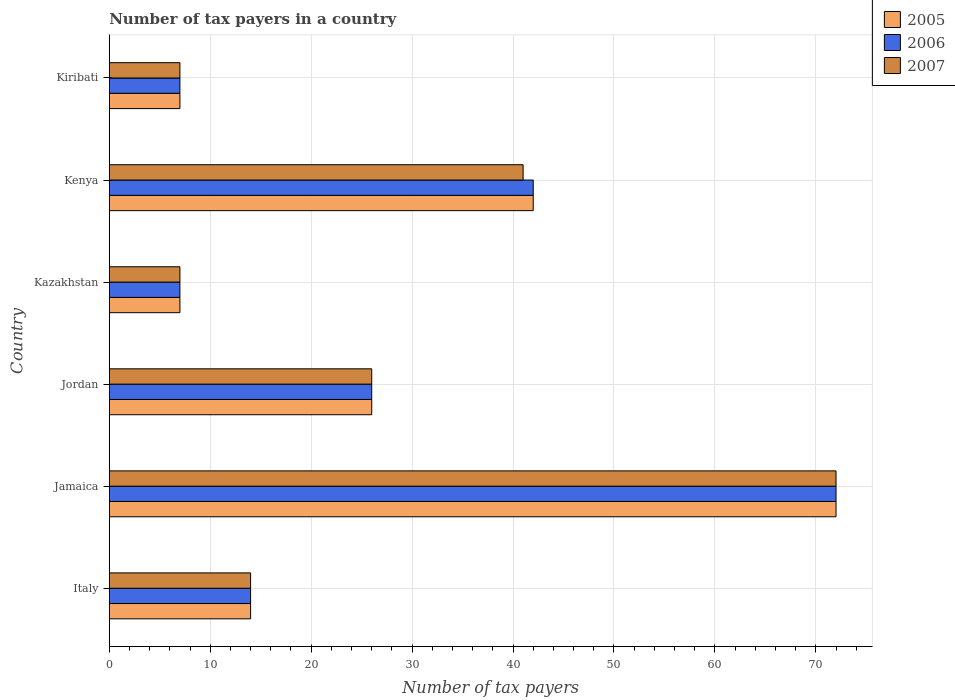How many bars are there on the 4th tick from the top?
Make the answer very short. 3. What is the label of the 3rd group of bars from the top?
Your answer should be compact. Kazakhstan. Across all countries, what is the maximum number of tax payers in in 2007?
Keep it short and to the point. 72. Across all countries, what is the minimum number of tax payers in in 2005?
Keep it short and to the point. 7. In which country was the number of tax payers in in 2006 maximum?
Provide a succinct answer. Jamaica. In which country was the number of tax payers in in 2006 minimum?
Offer a very short reply. Kazakhstan. What is the total number of tax payers in in 2007 in the graph?
Provide a succinct answer. 167. What is the difference between the number of tax payers in in 2007 in Jamaica and that in Kazakhstan?
Provide a short and direct response. 65. What is the difference between the number of tax payers in in 2007 in Italy and the number of tax payers in in 2005 in Jamaica?
Provide a short and direct response. -58. What is the difference between the number of tax payers in in 2006 and number of tax payers in in 2007 in Kenya?
Provide a succinct answer. 1. What is the ratio of the number of tax payers in in 2007 in Jordan to that in Kiribati?
Your response must be concise. 3.71. Is the difference between the number of tax payers in in 2006 in Jamaica and Kiribati greater than the difference between the number of tax payers in in 2007 in Jamaica and Kiribati?
Provide a succinct answer. No. What is the difference between the highest and the second highest number of tax payers in in 2005?
Your answer should be compact. 30. What is the difference between the highest and the lowest number of tax payers in in 2005?
Keep it short and to the point. 65. In how many countries, is the number of tax payers in in 2005 greater than the average number of tax payers in in 2005 taken over all countries?
Offer a very short reply. 2. Is the sum of the number of tax payers in in 2006 in Kazakhstan and Kiribati greater than the maximum number of tax payers in in 2005 across all countries?
Give a very brief answer. No. What does the 1st bar from the top in Kenya represents?
Your answer should be compact. 2007. What does the 1st bar from the bottom in Kenya represents?
Make the answer very short. 2005. What is the difference between two consecutive major ticks on the X-axis?
Your answer should be compact. 10. Are the values on the major ticks of X-axis written in scientific E-notation?
Give a very brief answer. No. Does the graph contain any zero values?
Offer a very short reply. No. Does the graph contain grids?
Provide a succinct answer. Yes. Where does the legend appear in the graph?
Your answer should be compact. Top right. What is the title of the graph?
Offer a terse response. Number of tax payers in a country. What is the label or title of the X-axis?
Give a very brief answer. Number of tax payers. What is the label or title of the Y-axis?
Your answer should be compact. Country. What is the Number of tax payers in 2005 in Italy?
Your answer should be very brief. 14. What is the Number of tax payers in 2006 in Italy?
Offer a terse response. 14. What is the Number of tax payers of 2006 in Jamaica?
Provide a succinct answer. 72. What is the Number of tax payers in 2007 in Jamaica?
Give a very brief answer. 72. What is the Number of tax payers in 2007 in Jordan?
Give a very brief answer. 26. What is the Number of tax payers in 2005 in Kenya?
Ensure brevity in your answer.  42. What is the Number of tax payers of 2006 in Kiribati?
Offer a terse response. 7. Across all countries, what is the maximum Number of tax payers in 2005?
Provide a short and direct response. 72. Across all countries, what is the maximum Number of tax payers of 2006?
Your response must be concise. 72. Across all countries, what is the minimum Number of tax payers in 2005?
Your response must be concise. 7. Across all countries, what is the minimum Number of tax payers in 2006?
Give a very brief answer. 7. Across all countries, what is the minimum Number of tax payers in 2007?
Provide a succinct answer. 7. What is the total Number of tax payers in 2005 in the graph?
Keep it short and to the point. 168. What is the total Number of tax payers of 2006 in the graph?
Offer a terse response. 168. What is the total Number of tax payers of 2007 in the graph?
Make the answer very short. 167. What is the difference between the Number of tax payers of 2005 in Italy and that in Jamaica?
Offer a terse response. -58. What is the difference between the Number of tax payers in 2006 in Italy and that in Jamaica?
Offer a terse response. -58. What is the difference between the Number of tax payers of 2007 in Italy and that in Jamaica?
Provide a short and direct response. -58. What is the difference between the Number of tax payers in 2006 in Italy and that in Jordan?
Give a very brief answer. -12. What is the difference between the Number of tax payers of 2007 in Italy and that in Jordan?
Keep it short and to the point. -12. What is the difference between the Number of tax payers of 2005 in Italy and that in Kazakhstan?
Provide a short and direct response. 7. What is the difference between the Number of tax payers in 2006 in Italy and that in Kenya?
Keep it short and to the point. -28. What is the difference between the Number of tax payers of 2006 in Italy and that in Kiribati?
Make the answer very short. 7. What is the difference between the Number of tax payers in 2006 in Jamaica and that in Jordan?
Your response must be concise. 46. What is the difference between the Number of tax payers of 2007 in Jamaica and that in Jordan?
Your answer should be very brief. 46. What is the difference between the Number of tax payers in 2006 in Jamaica and that in Kazakhstan?
Provide a short and direct response. 65. What is the difference between the Number of tax payers of 2007 in Jamaica and that in Kazakhstan?
Your response must be concise. 65. What is the difference between the Number of tax payers in 2005 in Jamaica and that in Kenya?
Your answer should be compact. 30. What is the difference between the Number of tax payers of 2005 in Jamaica and that in Kiribati?
Provide a succinct answer. 65. What is the difference between the Number of tax payers of 2007 in Jamaica and that in Kiribati?
Make the answer very short. 65. What is the difference between the Number of tax payers in 2006 in Jordan and that in Kazakhstan?
Ensure brevity in your answer.  19. What is the difference between the Number of tax payers in 2007 in Jordan and that in Kazakhstan?
Keep it short and to the point. 19. What is the difference between the Number of tax payers in 2005 in Jordan and that in Kenya?
Your response must be concise. -16. What is the difference between the Number of tax payers in 2006 in Jordan and that in Kenya?
Keep it short and to the point. -16. What is the difference between the Number of tax payers in 2007 in Jordan and that in Kenya?
Offer a very short reply. -15. What is the difference between the Number of tax payers in 2006 in Jordan and that in Kiribati?
Provide a short and direct response. 19. What is the difference between the Number of tax payers in 2005 in Kazakhstan and that in Kenya?
Offer a terse response. -35. What is the difference between the Number of tax payers of 2006 in Kazakhstan and that in Kenya?
Provide a short and direct response. -35. What is the difference between the Number of tax payers of 2007 in Kazakhstan and that in Kenya?
Provide a short and direct response. -34. What is the difference between the Number of tax payers of 2007 in Kazakhstan and that in Kiribati?
Provide a short and direct response. 0. What is the difference between the Number of tax payers in 2005 in Kenya and that in Kiribati?
Your response must be concise. 35. What is the difference between the Number of tax payers in 2006 in Kenya and that in Kiribati?
Your answer should be very brief. 35. What is the difference between the Number of tax payers of 2005 in Italy and the Number of tax payers of 2006 in Jamaica?
Provide a short and direct response. -58. What is the difference between the Number of tax payers of 2005 in Italy and the Number of tax payers of 2007 in Jamaica?
Keep it short and to the point. -58. What is the difference between the Number of tax payers of 2006 in Italy and the Number of tax payers of 2007 in Jamaica?
Your answer should be very brief. -58. What is the difference between the Number of tax payers in 2005 in Italy and the Number of tax payers in 2006 in Kazakhstan?
Offer a very short reply. 7. What is the difference between the Number of tax payers in 2005 in Italy and the Number of tax payers in 2007 in Kenya?
Make the answer very short. -27. What is the difference between the Number of tax payers of 2005 in Italy and the Number of tax payers of 2006 in Kiribati?
Offer a terse response. 7. What is the difference between the Number of tax payers of 2005 in Jamaica and the Number of tax payers of 2007 in Jordan?
Your answer should be compact. 46. What is the difference between the Number of tax payers in 2006 in Jamaica and the Number of tax payers in 2007 in Jordan?
Your answer should be compact. 46. What is the difference between the Number of tax payers of 2005 in Jamaica and the Number of tax payers of 2007 in Kazakhstan?
Provide a short and direct response. 65. What is the difference between the Number of tax payers of 2006 in Jamaica and the Number of tax payers of 2007 in Kazakhstan?
Ensure brevity in your answer.  65. What is the difference between the Number of tax payers of 2005 in Jamaica and the Number of tax payers of 2006 in Kenya?
Provide a succinct answer. 30. What is the difference between the Number of tax payers of 2005 in Jamaica and the Number of tax payers of 2006 in Kiribati?
Offer a terse response. 65. What is the difference between the Number of tax payers of 2005 in Jordan and the Number of tax payers of 2006 in Kazakhstan?
Offer a very short reply. 19. What is the difference between the Number of tax payers of 2006 in Jordan and the Number of tax payers of 2007 in Kazakhstan?
Your response must be concise. 19. What is the difference between the Number of tax payers of 2005 in Jordan and the Number of tax payers of 2006 in Kenya?
Provide a succinct answer. -16. What is the difference between the Number of tax payers in 2005 in Jordan and the Number of tax payers in 2007 in Kiribati?
Your answer should be compact. 19. What is the difference between the Number of tax payers in 2006 in Jordan and the Number of tax payers in 2007 in Kiribati?
Give a very brief answer. 19. What is the difference between the Number of tax payers of 2005 in Kazakhstan and the Number of tax payers of 2006 in Kenya?
Offer a terse response. -35. What is the difference between the Number of tax payers of 2005 in Kazakhstan and the Number of tax payers of 2007 in Kenya?
Keep it short and to the point. -34. What is the difference between the Number of tax payers of 2006 in Kazakhstan and the Number of tax payers of 2007 in Kenya?
Give a very brief answer. -34. What is the difference between the Number of tax payers in 2005 in Kazakhstan and the Number of tax payers in 2006 in Kiribati?
Provide a short and direct response. 0. What is the difference between the Number of tax payers of 2005 in Kazakhstan and the Number of tax payers of 2007 in Kiribati?
Provide a short and direct response. 0. What is the difference between the Number of tax payers in 2006 in Kazakhstan and the Number of tax payers in 2007 in Kiribati?
Your answer should be compact. 0. What is the difference between the Number of tax payers in 2005 in Kenya and the Number of tax payers in 2007 in Kiribati?
Your response must be concise. 35. What is the difference between the Number of tax payers of 2006 in Kenya and the Number of tax payers of 2007 in Kiribati?
Ensure brevity in your answer.  35. What is the average Number of tax payers in 2005 per country?
Make the answer very short. 28. What is the average Number of tax payers of 2007 per country?
Your answer should be very brief. 27.83. What is the difference between the Number of tax payers of 2005 and Number of tax payers of 2007 in Italy?
Your answer should be compact. 0. What is the difference between the Number of tax payers in 2005 and Number of tax payers in 2006 in Jamaica?
Offer a very short reply. 0. What is the difference between the Number of tax payers of 2005 and Number of tax payers of 2007 in Jamaica?
Keep it short and to the point. 0. What is the difference between the Number of tax payers in 2006 and Number of tax payers in 2007 in Jamaica?
Give a very brief answer. 0. What is the difference between the Number of tax payers of 2005 and Number of tax payers of 2007 in Jordan?
Make the answer very short. 0. What is the difference between the Number of tax payers in 2006 and Number of tax payers in 2007 in Jordan?
Provide a short and direct response. 0. What is the difference between the Number of tax payers of 2005 and Number of tax payers of 2006 in Kazakhstan?
Provide a short and direct response. 0. What is the difference between the Number of tax payers in 2006 and Number of tax payers in 2007 in Kazakhstan?
Offer a very short reply. 0. What is the difference between the Number of tax payers in 2005 and Number of tax payers in 2006 in Kenya?
Keep it short and to the point. 0. What is the difference between the Number of tax payers of 2005 and Number of tax payers of 2007 in Kenya?
Your response must be concise. 1. What is the difference between the Number of tax payers in 2006 and Number of tax payers in 2007 in Kenya?
Provide a short and direct response. 1. What is the difference between the Number of tax payers in 2005 and Number of tax payers in 2006 in Kiribati?
Offer a terse response. 0. What is the difference between the Number of tax payers of 2005 and Number of tax payers of 2007 in Kiribati?
Provide a short and direct response. 0. What is the ratio of the Number of tax payers in 2005 in Italy to that in Jamaica?
Your answer should be compact. 0.19. What is the ratio of the Number of tax payers of 2006 in Italy to that in Jamaica?
Your answer should be very brief. 0.19. What is the ratio of the Number of tax payers of 2007 in Italy to that in Jamaica?
Your answer should be very brief. 0.19. What is the ratio of the Number of tax payers in 2005 in Italy to that in Jordan?
Provide a short and direct response. 0.54. What is the ratio of the Number of tax payers in 2006 in Italy to that in Jordan?
Give a very brief answer. 0.54. What is the ratio of the Number of tax payers of 2007 in Italy to that in Jordan?
Make the answer very short. 0.54. What is the ratio of the Number of tax payers of 2005 in Italy to that in Kazakhstan?
Provide a succinct answer. 2. What is the ratio of the Number of tax payers in 2006 in Italy to that in Kazakhstan?
Your answer should be very brief. 2. What is the ratio of the Number of tax payers of 2007 in Italy to that in Kazakhstan?
Provide a short and direct response. 2. What is the ratio of the Number of tax payers of 2005 in Italy to that in Kenya?
Offer a terse response. 0.33. What is the ratio of the Number of tax payers of 2006 in Italy to that in Kenya?
Provide a short and direct response. 0.33. What is the ratio of the Number of tax payers of 2007 in Italy to that in Kenya?
Your response must be concise. 0.34. What is the ratio of the Number of tax payers in 2005 in Italy to that in Kiribati?
Your response must be concise. 2. What is the ratio of the Number of tax payers of 2005 in Jamaica to that in Jordan?
Your answer should be very brief. 2.77. What is the ratio of the Number of tax payers of 2006 in Jamaica to that in Jordan?
Provide a short and direct response. 2.77. What is the ratio of the Number of tax payers in 2007 in Jamaica to that in Jordan?
Offer a very short reply. 2.77. What is the ratio of the Number of tax payers of 2005 in Jamaica to that in Kazakhstan?
Your response must be concise. 10.29. What is the ratio of the Number of tax payers in 2006 in Jamaica to that in Kazakhstan?
Your answer should be very brief. 10.29. What is the ratio of the Number of tax payers of 2007 in Jamaica to that in Kazakhstan?
Keep it short and to the point. 10.29. What is the ratio of the Number of tax payers of 2005 in Jamaica to that in Kenya?
Your response must be concise. 1.71. What is the ratio of the Number of tax payers of 2006 in Jamaica to that in Kenya?
Your answer should be compact. 1.71. What is the ratio of the Number of tax payers in 2007 in Jamaica to that in Kenya?
Provide a succinct answer. 1.76. What is the ratio of the Number of tax payers in 2005 in Jamaica to that in Kiribati?
Make the answer very short. 10.29. What is the ratio of the Number of tax payers of 2006 in Jamaica to that in Kiribati?
Offer a terse response. 10.29. What is the ratio of the Number of tax payers of 2007 in Jamaica to that in Kiribati?
Make the answer very short. 10.29. What is the ratio of the Number of tax payers in 2005 in Jordan to that in Kazakhstan?
Offer a terse response. 3.71. What is the ratio of the Number of tax payers in 2006 in Jordan to that in Kazakhstan?
Provide a succinct answer. 3.71. What is the ratio of the Number of tax payers in 2007 in Jordan to that in Kazakhstan?
Your response must be concise. 3.71. What is the ratio of the Number of tax payers of 2005 in Jordan to that in Kenya?
Your answer should be compact. 0.62. What is the ratio of the Number of tax payers in 2006 in Jordan to that in Kenya?
Offer a very short reply. 0.62. What is the ratio of the Number of tax payers of 2007 in Jordan to that in Kenya?
Offer a terse response. 0.63. What is the ratio of the Number of tax payers of 2005 in Jordan to that in Kiribati?
Provide a short and direct response. 3.71. What is the ratio of the Number of tax payers in 2006 in Jordan to that in Kiribati?
Ensure brevity in your answer.  3.71. What is the ratio of the Number of tax payers of 2007 in Jordan to that in Kiribati?
Provide a succinct answer. 3.71. What is the ratio of the Number of tax payers of 2007 in Kazakhstan to that in Kenya?
Provide a succinct answer. 0.17. What is the ratio of the Number of tax payers in 2006 in Kazakhstan to that in Kiribati?
Make the answer very short. 1. What is the ratio of the Number of tax payers in 2005 in Kenya to that in Kiribati?
Give a very brief answer. 6. What is the ratio of the Number of tax payers in 2006 in Kenya to that in Kiribati?
Your answer should be compact. 6. What is the ratio of the Number of tax payers in 2007 in Kenya to that in Kiribati?
Make the answer very short. 5.86. What is the difference between the highest and the second highest Number of tax payers of 2005?
Make the answer very short. 30. What is the difference between the highest and the second highest Number of tax payers of 2006?
Your response must be concise. 30. What is the difference between the highest and the second highest Number of tax payers of 2007?
Offer a terse response. 31. What is the difference between the highest and the lowest Number of tax payers of 2005?
Keep it short and to the point. 65. 